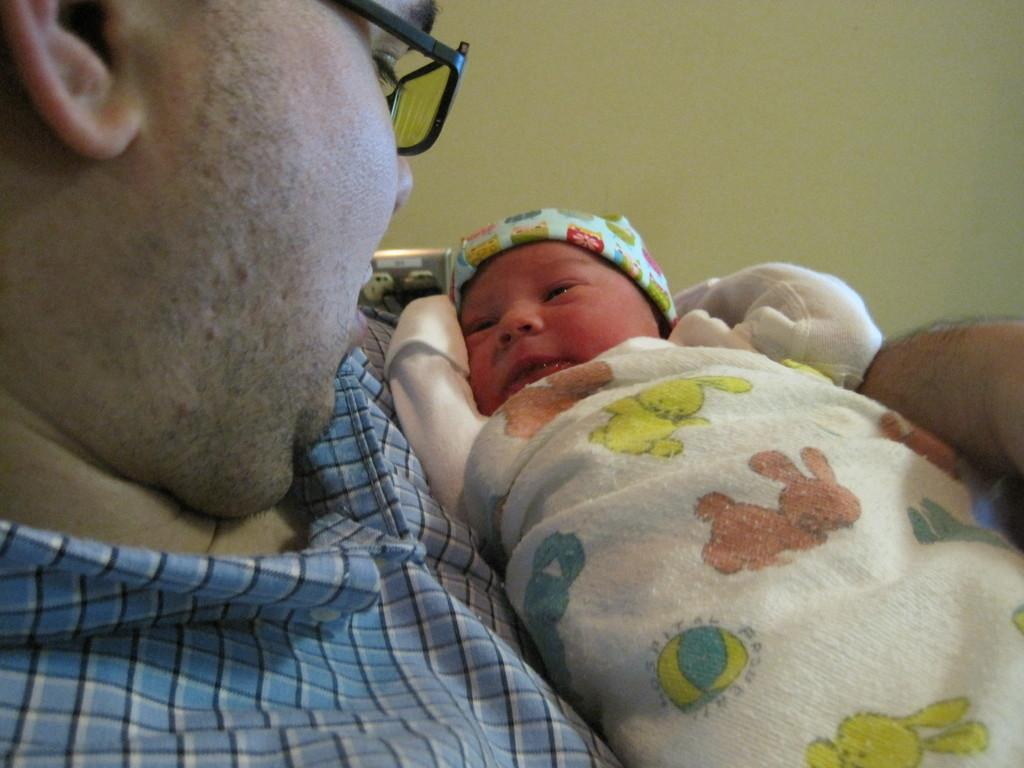Who is in the image? There is a man in the image. What is the man doing in the image? The man is holding a baby. What is the man wearing in the image? The man is wearing a shirt and glasses. What can be seen in the background of the image? There is a wall visible in the image. What type of bed is the man running on in the image? There is no bed or running depicted in the image; it features a man holding a baby. 